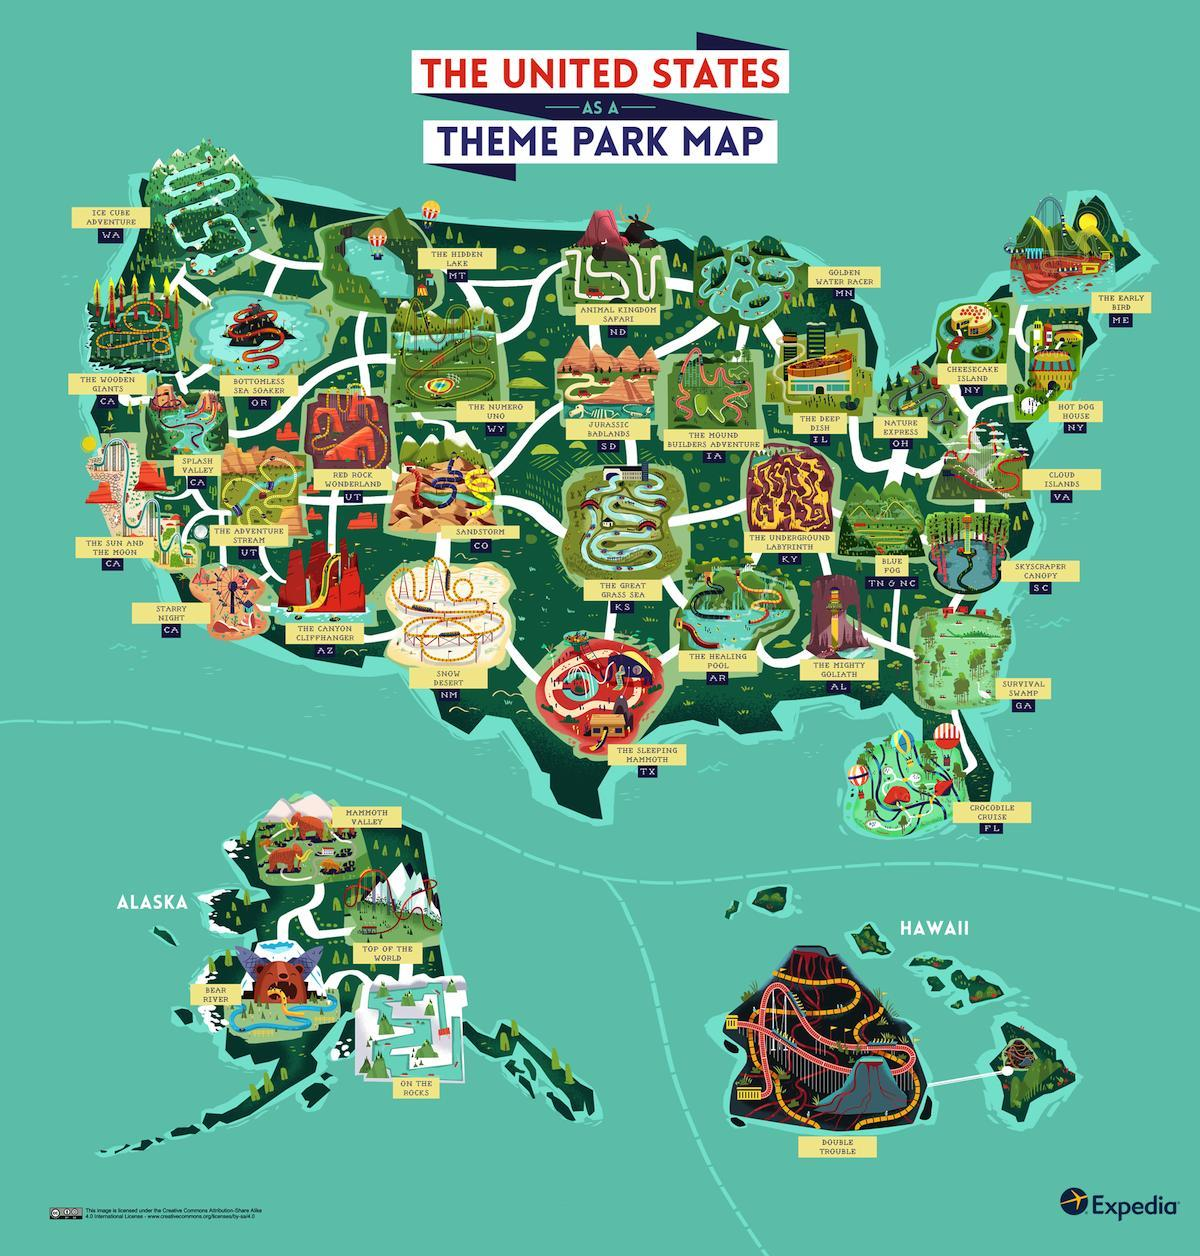which park in texas
Answer the question with a short phrase. the sleeping mammoth what is the desert covered in snow how many parks in alaska 4 how many parks in new york 2 what is the name of the park in hawaii double trouble 